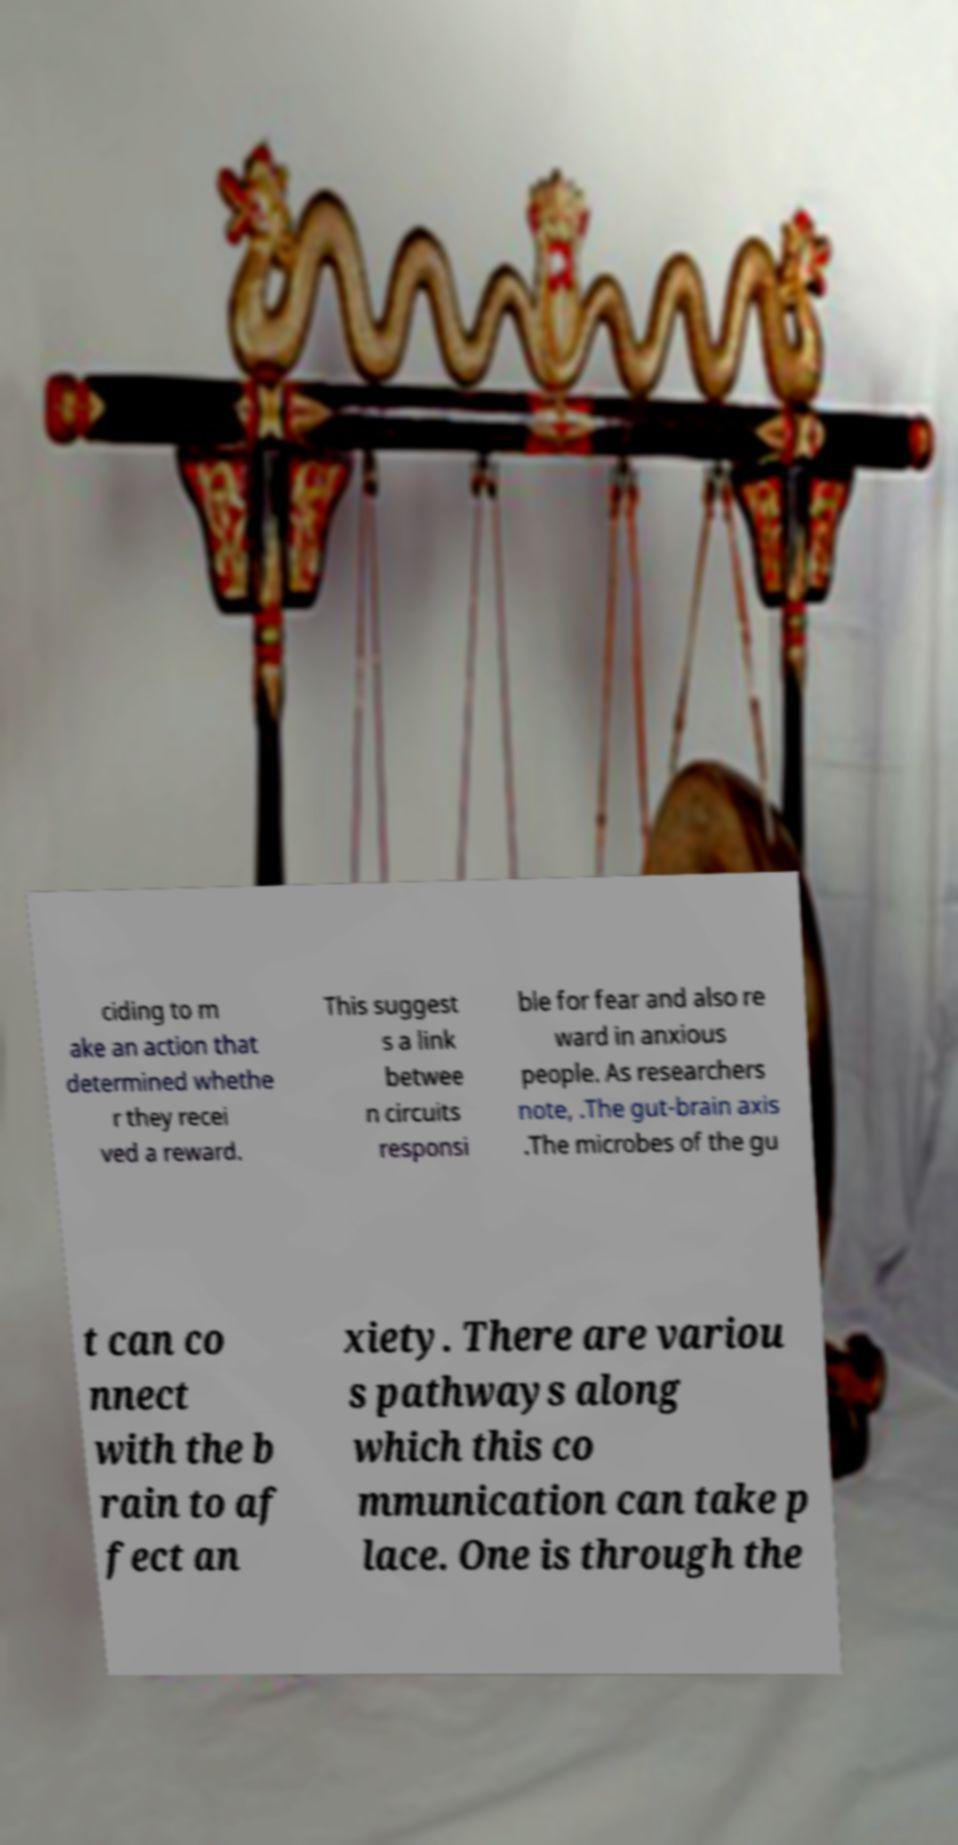Please read and relay the text visible in this image. What does it say? ciding to m ake an action that determined whethe r they recei ved a reward. This suggest s a link betwee n circuits responsi ble for fear and also re ward in anxious people. As researchers note, .The gut-brain axis .The microbes of the gu t can co nnect with the b rain to af fect an xiety. There are variou s pathways along which this co mmunication can take p lace. One is through the 